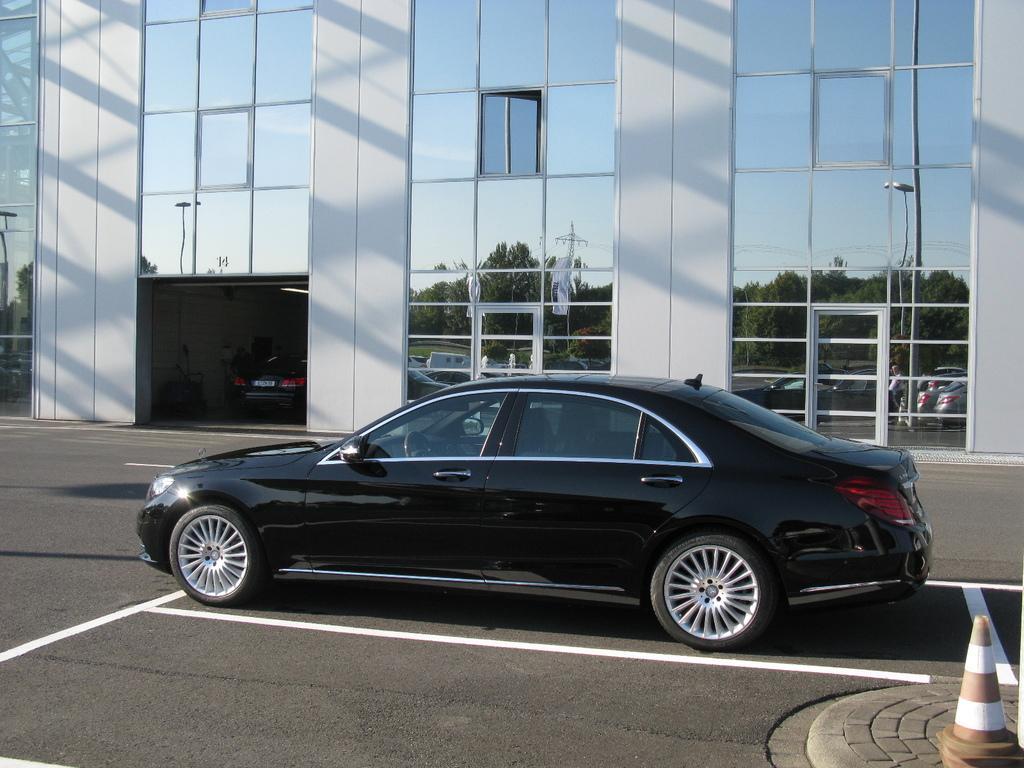In one or two sentences, can you explain what this image depicts? In this picture there is a car in the center of the image and there is glass building behind the car, there is a traffic cone in the bottom right side of the image and there is another car inside the building. 